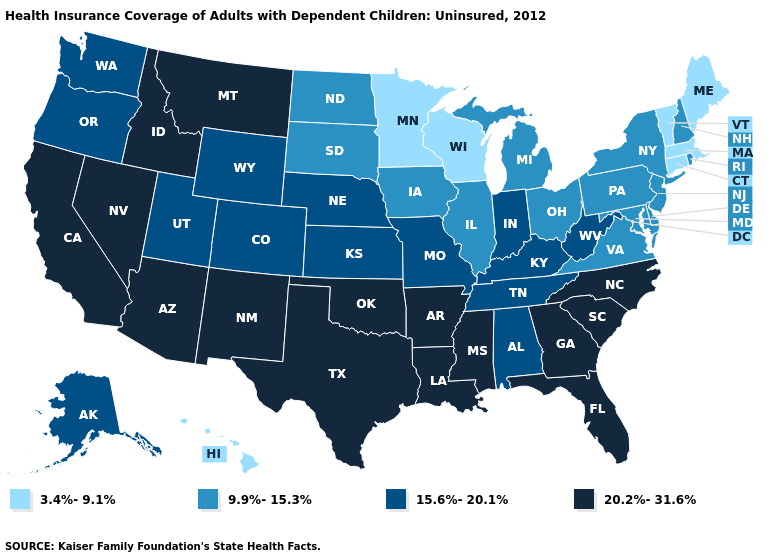What is the lowest value in the USA?
Quick response, please. 3.4%-9.1%. Which states have the highest value in the USA?
Short answer required. Arizona, Arkansas, California, Florida, Georgia, Idaho, Louisiana, Mississippi, Montana, Nevada, New Mexico, North Carolina, Oklahoma, South Carolina, Texas. What is the lowest value in states that border Idaho?
Concise answer only. 15.6%-20.1%. What is the value of Maine?
Write a very short answer. 3.4%-9.1%. Name the states that have a value in the range 3.4%-9.1%?
Keep it brief. Connecticut, Hawaii, Maine, Massachusetts, Minnesota, Vermont, Wisconsin. What is the value of Michigan?
Concise answer only. 9.9%-15.3%. Which states hav the highest value in the South?
Be succinct. Arkansas, Florida, Georgia, Louisiana, Mississippi, North Carolina, Oklahoma, South Carolina, Texas. Is the legend a continuous bar?
Keep it brief. No. How many symbols are there in the legend?
Concise answer only. 4. Does Connecticut have the lowest value in the USA?
Quick response, please. Yes. Among the states that border Louisiana , which have the lowest value?
Answer briefly. Arkansas, Mississippi, Texas. Does the map have missing data?
Be succinct. No. What is the lowest value in the USA?
Give a very brief answer. 3.4%-9.1%. Does the first symbol in the legend represent the smallest category?
Concise answer only. Yes. 